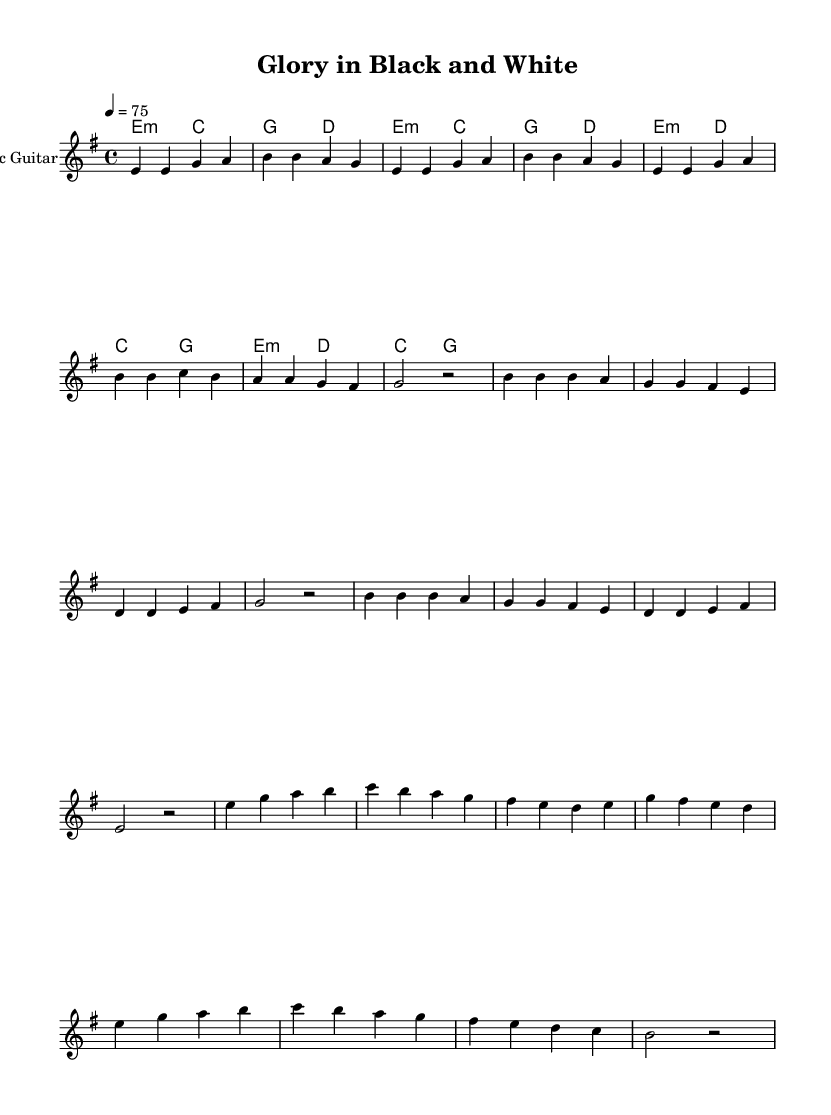What is the key signature of this music? The key signature is indicated by the 'e' note at the beginning of the score. It features one sharp, which corresponds to E minor.
Answer: E minor What is the time signature of this piece? The time signature is shown as "4/4" at the beginning of the score. This means there are four beats in a measure, and a quarter note gets one beat.
Answer: 4/4 What is the tempo marking for this music? The tempo is indicated by "4 = 75", meaning there are 75 beats per minute, with each quarter note getting one beat.
Answer: 75 How many measures are in the verse? By counting the number of groups separated by the vertical lines in the verse melody, we observe that there are 8 measures in total.
Answer: 8 What is the lyrical theme expressed in the chorus? The lyrics of the chorus contain themes of glory and resilience, highlighting the determination of Botafogo fans. The phrase "Rising from the ashes" signifies overcoming challenges.
Answer: Glory and resilience What instrument is primarily featured in this score? The score explicitly states "Electric Guitar" as the instrument name in the staff, indicating that this is the primary feature of the arrangement.
Answer: Electric Guitar What type of chords are primarily used during the chorus? The chord progression used in the chorus is a mix of minor and major chords, evidenced by the use of 'e2:m', 'd', 'c', and 'g' chords.
Answer: Minor and major chords 